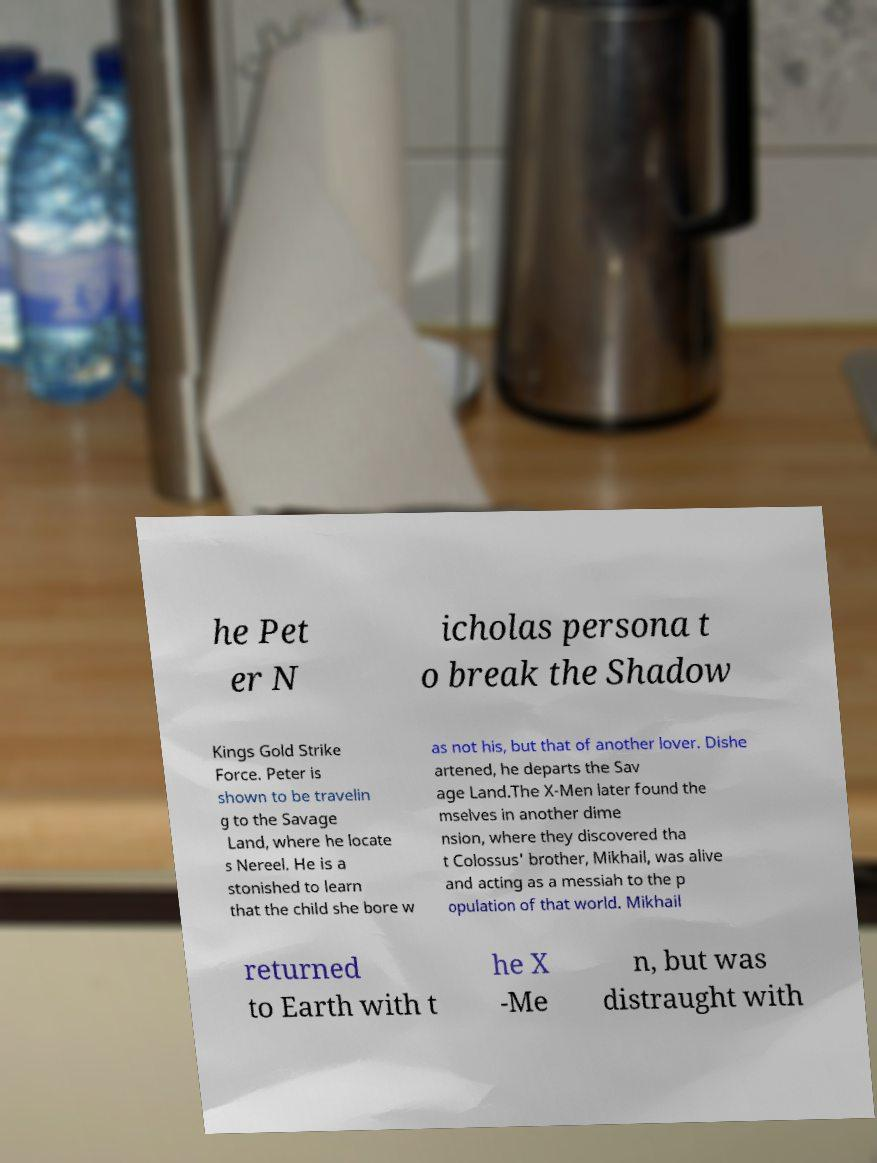Please read and relay the text visible in this image. What does it say? he Pet er N icholas persona t o break the Shadow Kings Gold Strike Force. Peter is shown to be travelin g to the Savage Land, where he locate s Nereel. He is a stonished to learn that the child she bore w as not his, but that of another lover. Dishe artened, he departs the Sav age Land.The X-Men later found the mselves in another dime nsion, where they discovered tha t Colossus' brother, Mikhail, was alive and acting as a messiah to the p opulation of that world. Mikhail returned to Earth with t he X -Me n, but was distraught with 